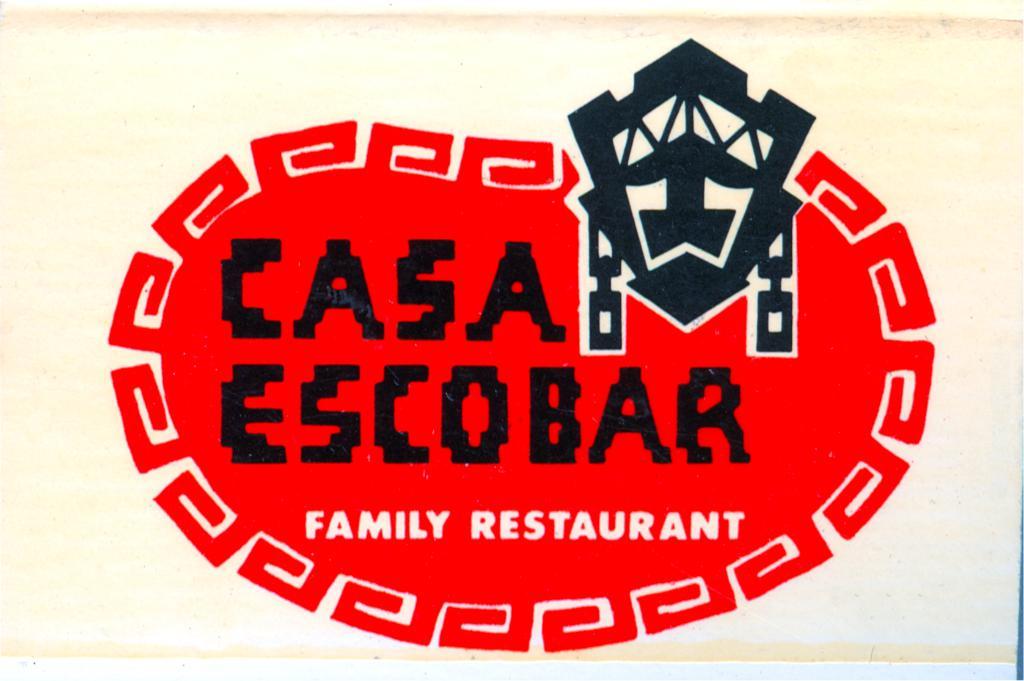What kind of a restaurant is casa escobar?
Keep it short and to the point. Family. What is the restaurant name?
Your answer should be compact. Casa escobar. 